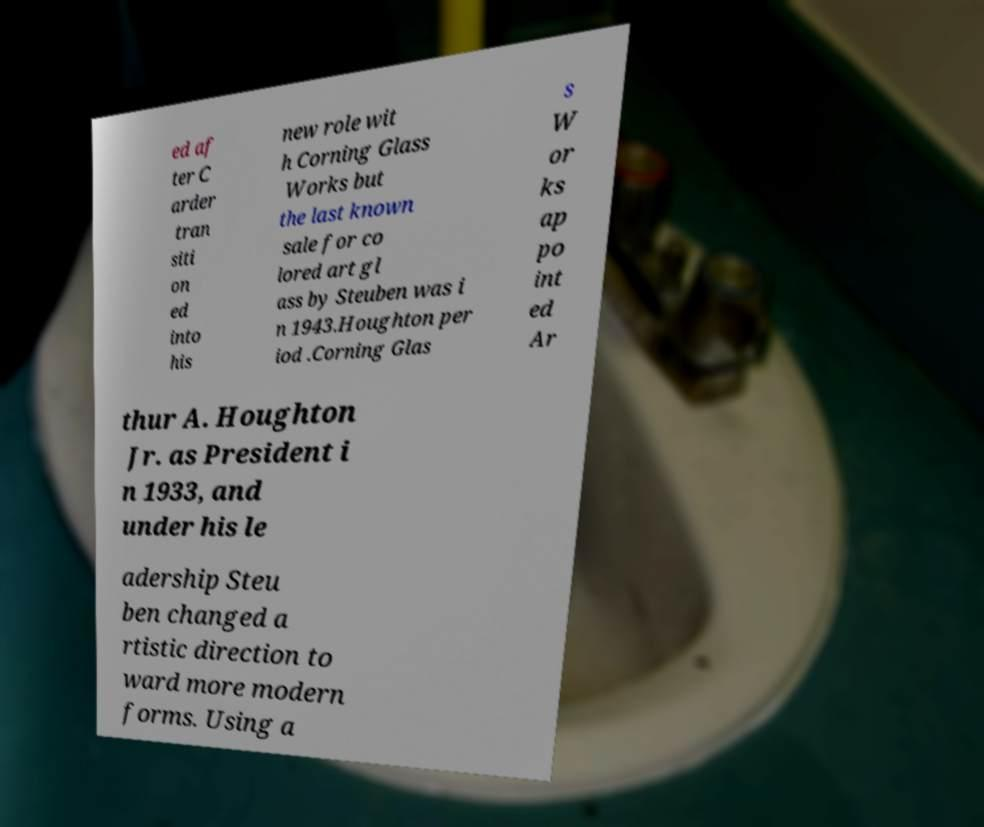Could you extract and type out the text from this image? ed af ter C arder tran siti on ed into his new role wit h Corning Glass Works but the last known sale for co lored art gl ass by Steuben was i n 1943.Houghton per iod .Corning Glas s W or ks ap po int ed Ar thur A. Houghton Jr. as President i n 1933, and under his le adership Steu ben changed a rtistic direction to ward more modern forms. Using a 